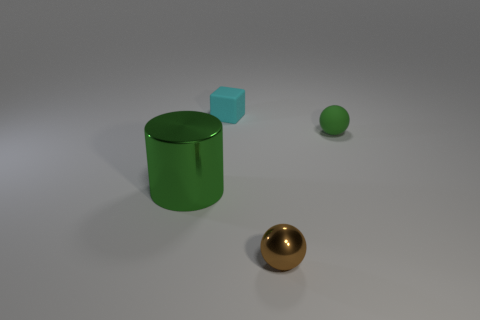Are there any other things that are the same shape as the green metal thing?
Your response must be concise. No. Is there any other thing that is the same size as the green metal object?
Give a very brief answer. No. What number of other objects are the same size as the cyan object?
Your response must be concise. 2. What is the size of the rubber thing that is the same color as the big shiny cylinder?
Your answer should be very brief. Small. Are there more big shiny cylinders on the right side of the tiny rubber sphere than small green matte balls?
Your answer should be compact. No. Is there a metallic sphere of the same color as the cylinder?
Provide a short and direct response. No. What is the color of the other ball that is the same size as the green rubber ball?
Provide a succinct answer. Brown. There is a thing that is behind the green rubber thing; how many green metallic cylinders are on the right side of it?
Your answer should be very brief. 0. How many things are either small things behind the green metal cylinder or matte spheres?
Offer a very short reply. 2. What number of green balls are the same material as the small cyan thing?
Offer a very short reply. 1. 